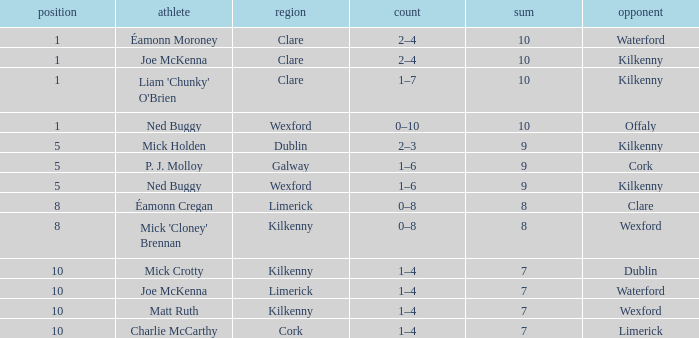Which County has a Rank larger than 8, and a Player of joe mckenna? Limerick. 